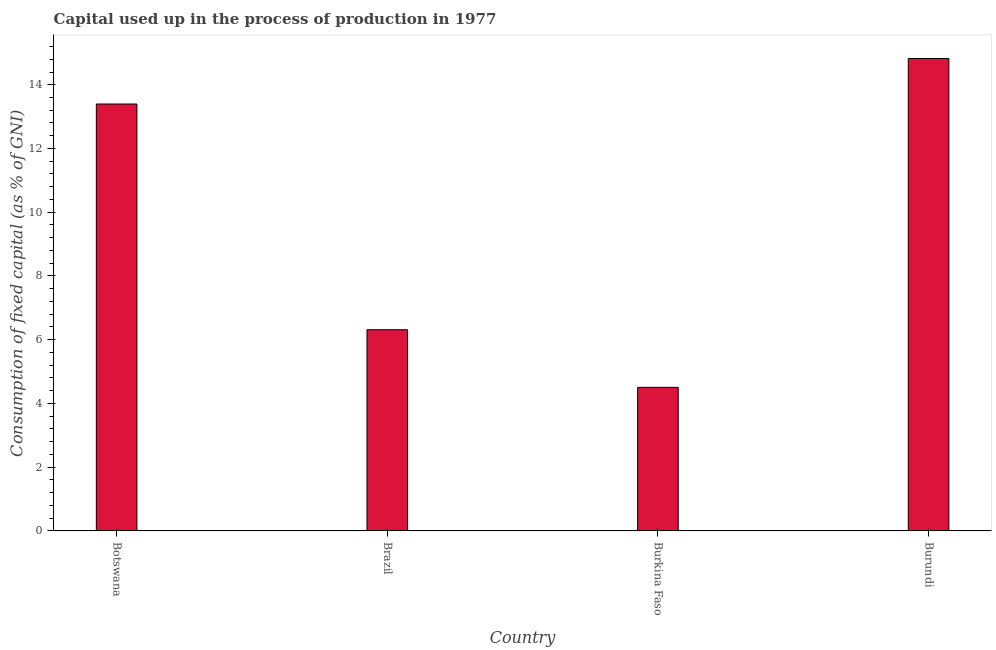Does the graph contain grids?
Offer a terse response. No. What is the title of the graph?
Ensure brevity in your answer.  Capital used up in the process of production in 1977. What is the label or title of the X-axis?
Your answer should be very brief. Country. What is the label or title of the Y-axis?
Offer a very short reply. Consumption of fixed capital (as % of GNI). What is the consumption of fixed capital in Burundi?
Make the answer very short. 14.82. Across all countries, what is the maximum consumption of fixed capital?
Provide a short and direct response. 14.82. Across all countries, what is the minimum consumption of fixed capital?
Ensure brevity in your answer.  4.51. In which country was the consumption of fixed capital maximum?
Provide a short and direct response. Burundi. In which country was the consumption of fixed capital minimum?
Keep it short and to the point. Burkina Faso. What is the sum of the consumption of fixed capital?
Provide a succinct answer. 39.04. What is the difference between the consumption of fixed capital in Botswana and Brazil?
Offer a very short reply. 7.08. What is the average consumption of fixed capital per country?
Provide a short and direct response. 9.76. What is the median consumption of fixed capital?
Offer a very short reply. 9.85. In how many countries, is the consumption of fixed capital greater than 4.8 %?
Provide a succinct answer. 3. What is the ratio of the consumption of fixed capital in Burkina Faso to that in Burundi?
Give a very brief answer. 0.3. Is the consumption of fixed capital in Botswana less than that in Brazil?
Provide a succinct answer. No. Is the difference between the consumption of fixed capital in Botswana and Brazil greater than the difference between any two countries?
Ensure brevity in your answer.  No. What is the difference between the highest and the second highest consumption of fixed capital?
Make the answer very short. 1.43. What is the difference between the highest and the lowest consumption of fixed capital?
Make the answer very short. 10.32. Are all the bars in the graph horizontal?
Provide a short and direct response. No. How many countries are there in the graph?
Offer a very short reply. 4. What is the Consumption of fixed capital (as % of GNI) in Botswana?
Provide a short and direct response. 13.4. What is the Consumption of fixed capital (as % of GNI) in Brazil?
Give a very brief answer. 6.31. What is the Consumption of fixed capital (as % of GNI) in Burkina Faso?
Your answer should be very brief. 4.51. What is the Consumption of fixed capital (as % of GNI) of Burundi?
Keep it short and to the point. 14.82. What is the difference between the Consumption of fixed capital (as % of GNI) in Botswana and Brazil?
Keep it short and to the point. 7.08. What is the difference between the Consumption of fixed capital (as % of GNI) in Botswana and Burkina Faso?
Your answer should be compact. 8.89. What is the difference between the Consumption of fixed capital (as % of GNI) in Botswana and Burundi?
Provide a succinct answer. -1.43. What is the difference between the Consumption of fixed capital (as % of GNI) in Brazil and Burkina Faso?
Make the answer very short. 1.81. What is the difference between the Consumption of fixed capital (as % of GNI) in Brazil and Burundi?
Keep it short and to the point. -8.51. What is the difference between the Consumption of fixed capital (as % of GNI) in Burkina Faso and Burundi?
Provide a succinct answer. -10.32. What is the ratio of the Consumption of fixed capital (as % of GNI) in Botswana to that in Brazil?
Ensure brevity in your answer.  2.12. What is the ratio of the Consumption of fixed capital (as % of GNI) in Botswana to that in Burkina Faso?
Your answer should be very brief. 2.97. What is the ratio of the Consumption of fixed capital (as % of GNI) in Botswana to that in Burundi?
Your answer should be compact. 0.9. What is the ratio of the Consumption of fixed capital (as % of GNI) in Brazil to that in Burkina Faso?
Give a very brief answer. 1.4. What is the ratio of the Consumption of fixed capital (as % of GNI) in Brazil to that in Burundi?
Offer a terse response. 0.43. What is the ratio of the Consumption of fixed capital (as % of GNI) in Burkina Faso to that in Burundi?
Offer a terse response. 0.3. 